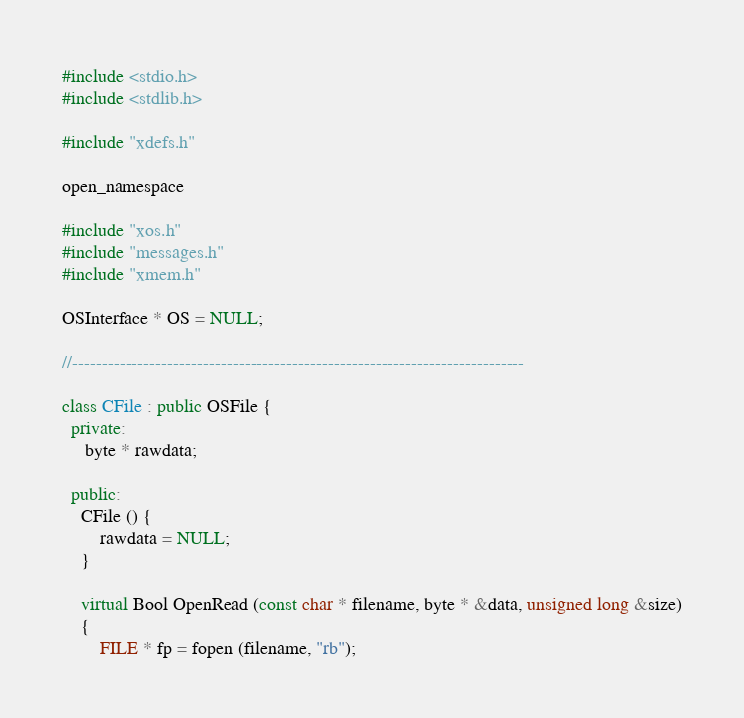<code> <loc_0><loc_0><loc_500><loc_500><_C++_>
#include <stdio.h>
#include <stdlib.h>

#include "xdefs.h"

open_namespace

#include "xos.h"
#include "messages.h"
#include "xmem.h"

OSInterface * OS = NULL;

//----------------------------------------------------------------------------

class CFile : public OSFile {
  private:
     byte * rawdata;

  public:
    CFile () {
        rawdata = NULL;
    }

    virtual Bool OpenRead (const char * filename, byte * &data, unsigned long &size)
    {
        FILE * fp = fopen (filename, "rb");</code> 